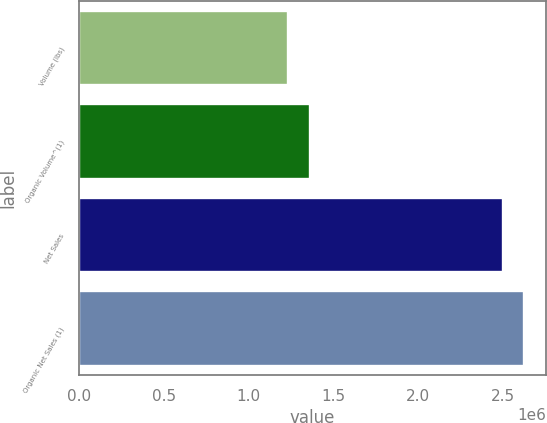<chart> <loc_0><loc_0><loc_500><loc_500><bar_chart><fcel>Volume (lbs)<fcel>Organic Volume^(1)<fcel>Net Sales<fcel>Organic Net Sales (1)<nl><fcel>1.23688e+06<fcel>1.36334e+06<fcel>2.50151e+06<fcel>2.62798e+06<nl></chart> 